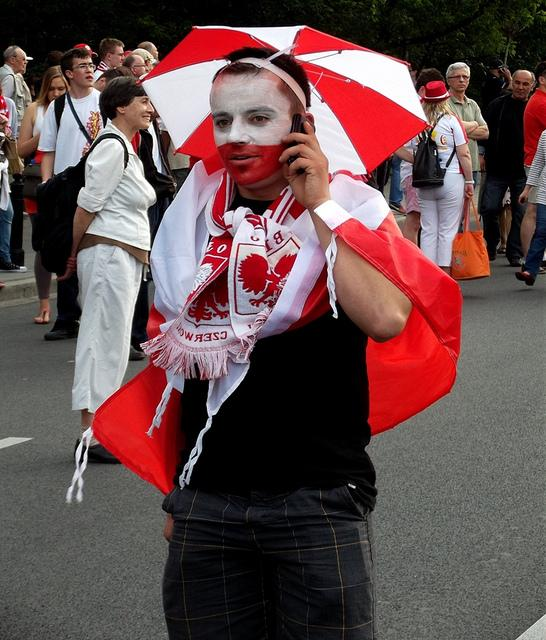Which country has red with white flag? poland 